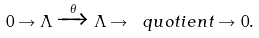<formula> <loc_0><loc_0><loc_500><loc_500>0 \rightarrow \Lambda \xrightarrow { \theta } \Lambda \rightarrow \ q u o t i e n t \rightarrow 0 .</formula> 